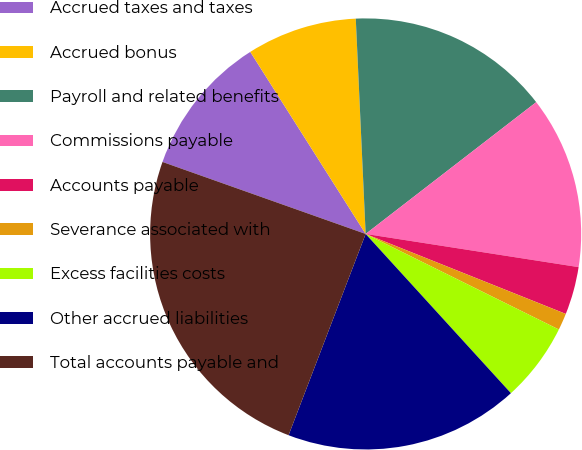Convert chart. <chart><loc_0><loc_0><loc_500><loc_500><pie_chart><fcel>Accrued taxes and taxes<fcel>Accrued bonus<fcel>Payroll and related benefits<fcel>Commissions payable<fcel>Accounts payable<fcel>Severance associated with<fcel>Excess facilities costs<fcel>Other accrued liabilities<fcel>Total accounts payable and<nl><fcel>10.59%<fcel>8.26%<fcel>15.26%<fcel>12.93%<fcel>3.59%<fcel>1.26%<fcel>5.92%<fcel>17.59%<fcel>24.6%<nl></chart> 